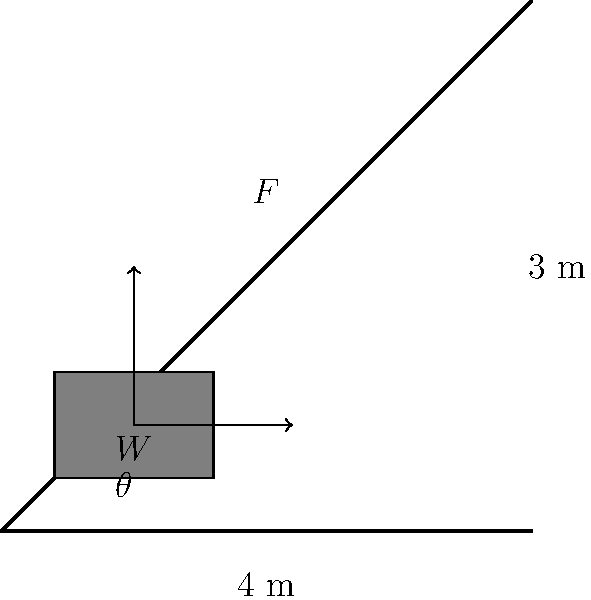A vintage couch weighing 800 N needs to be lifted up a flight of stairs in a Manhattan apartment building. To make the task easier, you decide to use a smooth ramp as a simple machine. The stairs have a vertical height of 3 m and a horizontal length of 4 m. Assuming the coefficient of friction between the couch and the ramp is 0.2, calculate the magnitude of the force parallel to the ramp needed to lift the couch at a constant velocity. Let's approach this step-by-step:

1) First, we need to find the angle of inclination ($\theta$) of the ramp:
   $$\tan \theta = \frac{\text{vertical height}}{\text{horizontal length}} = \frac{3}{4}$$
   $$\theta = \arctan(\frac{3}{4}) \approx 36.87°$$

2) The forces acting on the couch are:
   - Weight (W) = 800 N
   - Normal force (N)
   - Friction force (f)
   - Applied force (F) parallel to the ramp

3) Resolve the weight into components parallel and perpendicular to the ramp:
   - Weight parallel to ramp: $W \sin \theta$
   - Weight perpendicular to ramp: $W \cos \theta$

4) The normal force is equal to the component of weight perpendicular to the ramp:
   $$N = W \cos \theta$$

5) The friction force is:
   $$f = \mu N = \mu W \cos \theta$$
   where $\mu = 0.2$ (given coefficient of friction)

6) For constant velocity, the sum of forces parallel to the ramp must be zero:
   $$F - W \sin \theta - f = 0$$

7) Substituting the friction force:
   $$F - W \sin \theta - \mu W \cos \theta = 0$$

8) Solving for F:
   $$F = W \sin \theta + \mu W \cos \theta$$
   $$F = W (\sin \theta + \mu \cos \theta)$$

9) Plugging in the values:
   $$F = 800 (\sin 36.87° + 0.2 \cos 36.87°)$$
   $$F = 800 (0.6 + 0.2 * 0.8) = 800 * 0.76 = 608 N$$
Answer: 608 N 